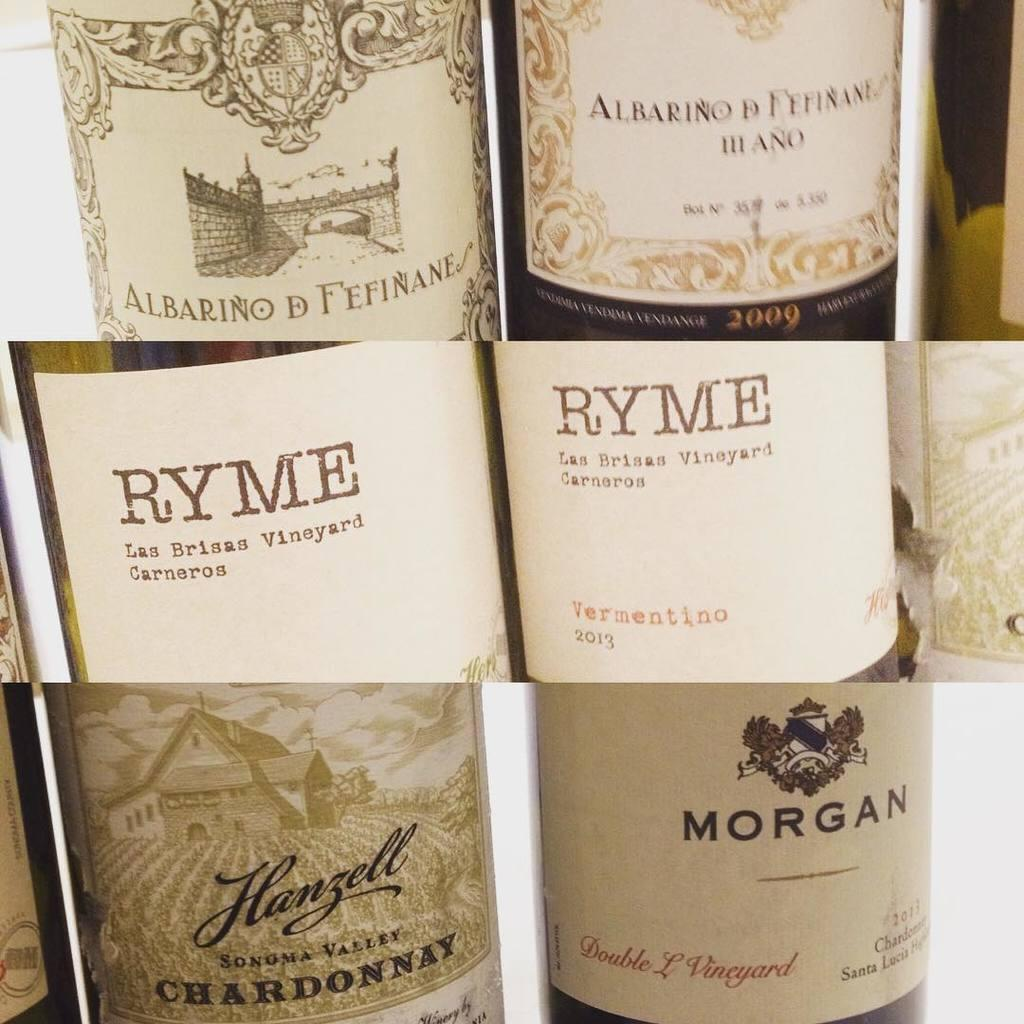What is the main subject of the image? The main subject of the image is a collage of pictures. Can you describe any specific items featured in the collage? Yes, the collage features a beverage bottle. What type of wine is the queen drinking in the image? There is no queen or wine present in the image; it contains a collage of pictures featuring a beverage bottle. 